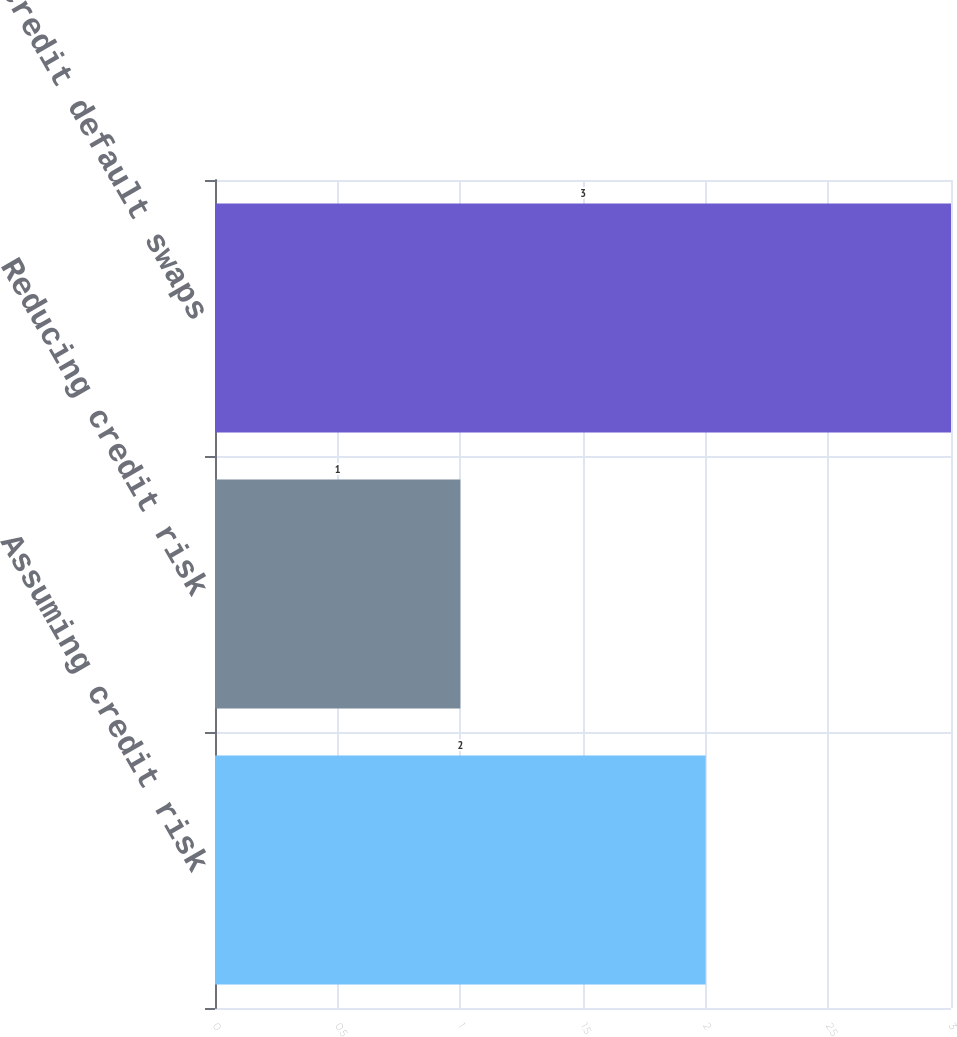Convert chart. <chart><loc_0><loc_0><loc_500><loc_500><bar_chart><fcel>Assuming credit risk<fcel>Reducing credit risk<fcel>Total credit default swaps<nl><fcel>2<fcel>1<fcel>3<nl></chart> 